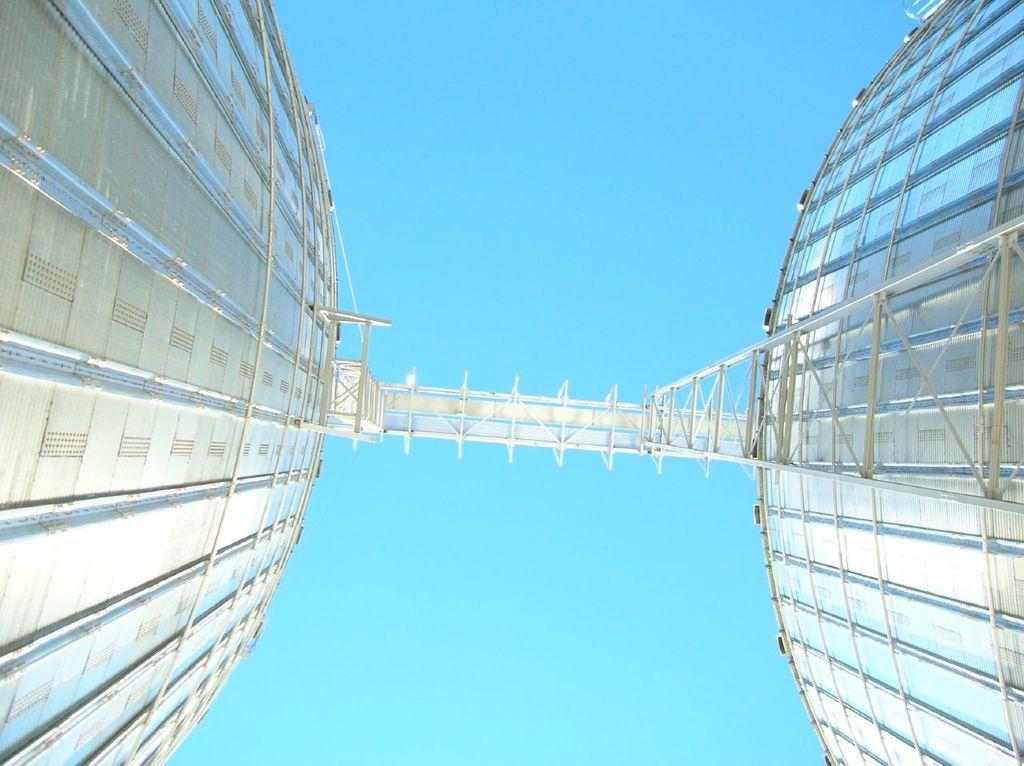In one or two sentences, can you explain what this image depicts? In this picture we can see there are some metal towers and in between the towers there is a bridge. Behind the towers there is a sky. 